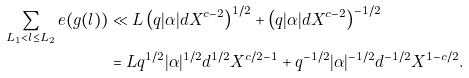Convert formula to latex. <formula><loc_0><loc_0><loc_500><loc_500>\sum _ { L _ { 1 } < l \leq L _ { 2 } } e ( g ( l ) ) & \ll L \left ( q | \alpha | d X ^ { c - 2 } \right ) ^ { 1 / 2 } + \left ( q | \alpha | d X ^ { c - 2 } \right ) ^ { - 1 / 2 } \\ & = L q ^ { 1 / 2 } | \alpha | ^ { 1 / 2 } d ^ { 1 / 2 } X ^ { c / 2 - 1 } + q ^ { - 1 / 2 } | \alpha | ^ { - 1 / 2 } d ^ { - 1 / 2 } X ^ { 1 - c / 2 } .</formula> 